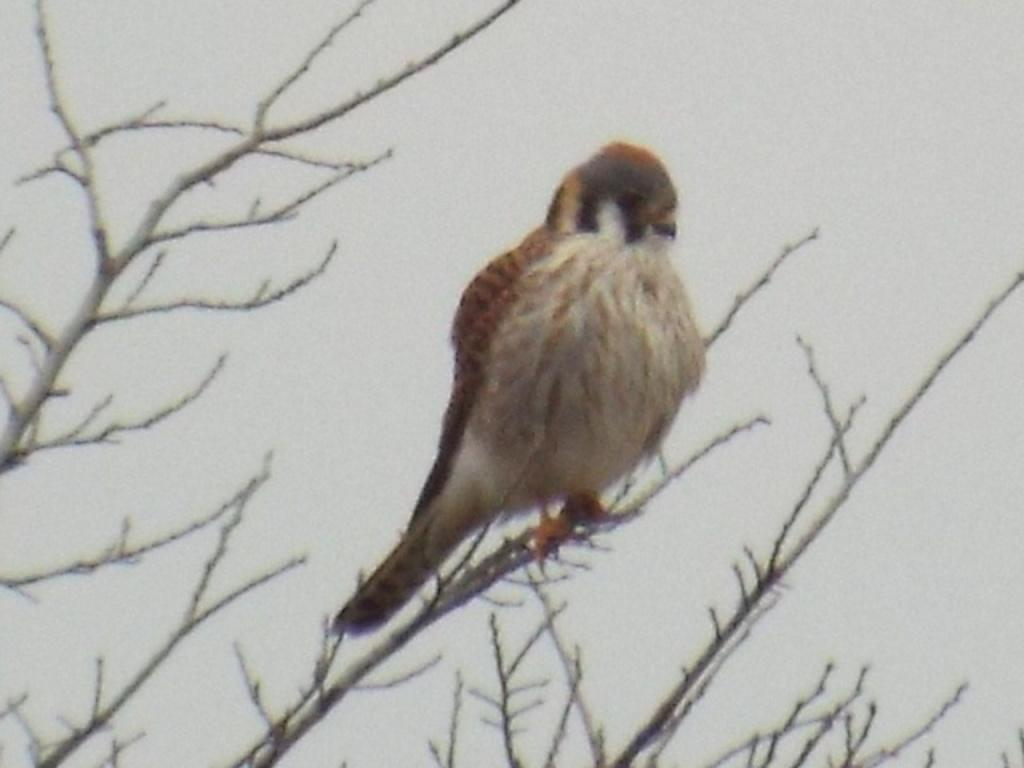What type of animal can be seen in the image? There is a bird on a tree in the image. What is visible in the background of the image? The sky is visible in the background of the image. How many ducks are swimming in the pond in the image? There is no pond or ducks present in the image; it features a bird on a tree and the sky in the background. 